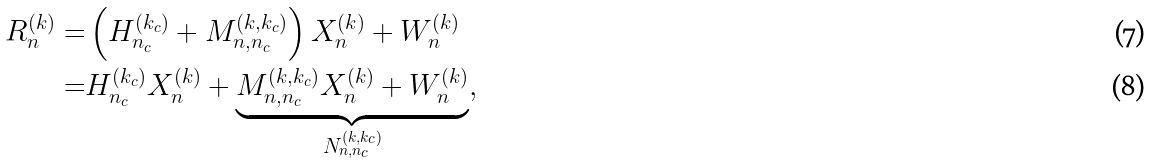<formula> <loc_0><loc_0><loc_500><loc_500>R _ { n } ^ { ( k ) } = & \left ( H _ { n _ { c } } ^ { ( k _ { c } ) } + M _ { n , n _ { c } } ^ { ( k , k _ { c } ) } \right ) X _ { n } ^ { ( k ) } + W _ { n } ^ { ( k ) } \\ = & H _ { n _ { c } } ^ { ( k _ { c } ) } X _ { n } ^ { ( k ) } + \underbrace { M _ { n , n _ { c } } ^ { ( k , k _ { c } ) } X _ { n } ^ { ( k ) } + W _ { n } ^ { ( k ) } } _ { N _ { n , n _ { c } } ^ { ( k , k _ { c } ) } } ,</formula> 